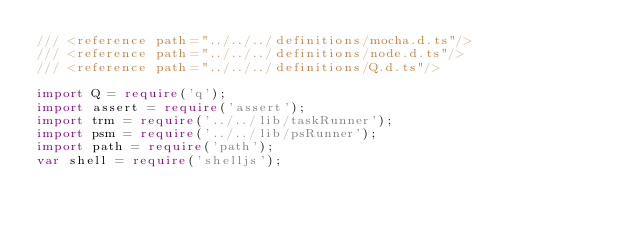Convert code to text. <code><loc_0><loc_0><loc_500><loc_500><_TypeScript_>/// <reference path="../../../definitions/mocha.d.ts"/>
/// <reference path="../../../definitions/node.d.ts"/>
/// <reference path="../../../definitions/Q.d.ts"/>

import Q = require('q');
import assert = require('assert');
import trm = require('../../lib/taskRunner');
import psm = require('../../lib/psRunner');
import path = require('path');
var shell = require('shelljs');</code> 